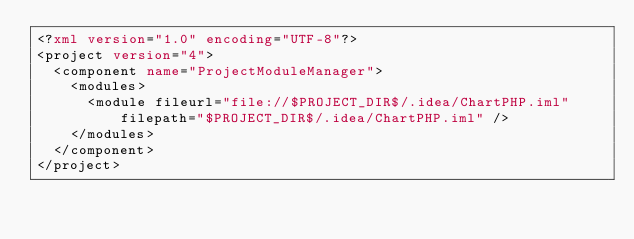<code> <loc_0><loc_0><loc_500><loc_500><_XML_><?xml version="1.0" encoding="UTF-8"?>
<project version="4">
  <component name="ProjectModuleManager">
    <modules>
      <module fileurl="file://$PROJECT_DIR$/.idea/ChartPHP.iml" filepath="$PROJECT_DIR$/.idea/ChartPHP.iml" />
    </modules>
  </component>
</project></code> 